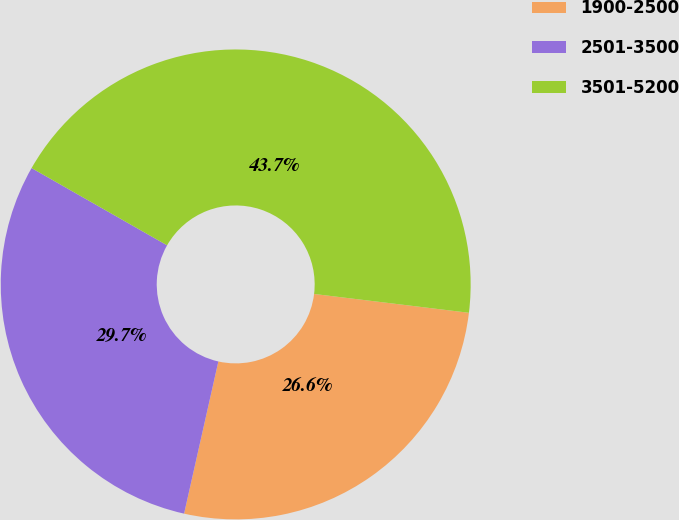Convert chart. <chart><loc_0><loc_0><loc_500><loc_500><pie_chart><fcel>1900-2500<fcel>2501-3500<fcel>3501-5200<nl><fcel>26.6%<fcel>29.72%<fcel>43.68%<nl></chart> 